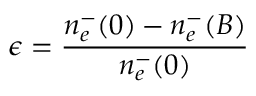Convert formula to latex. <formula><loc_0><loc_0><loc_500><loc_500>\epsilon = \frac { n _ { e } ^ { - } ( 0 ) - n _ { e } ^ { - } ( B ) } { n _ { e } ^ { - } ( 0 ) }</formula> 